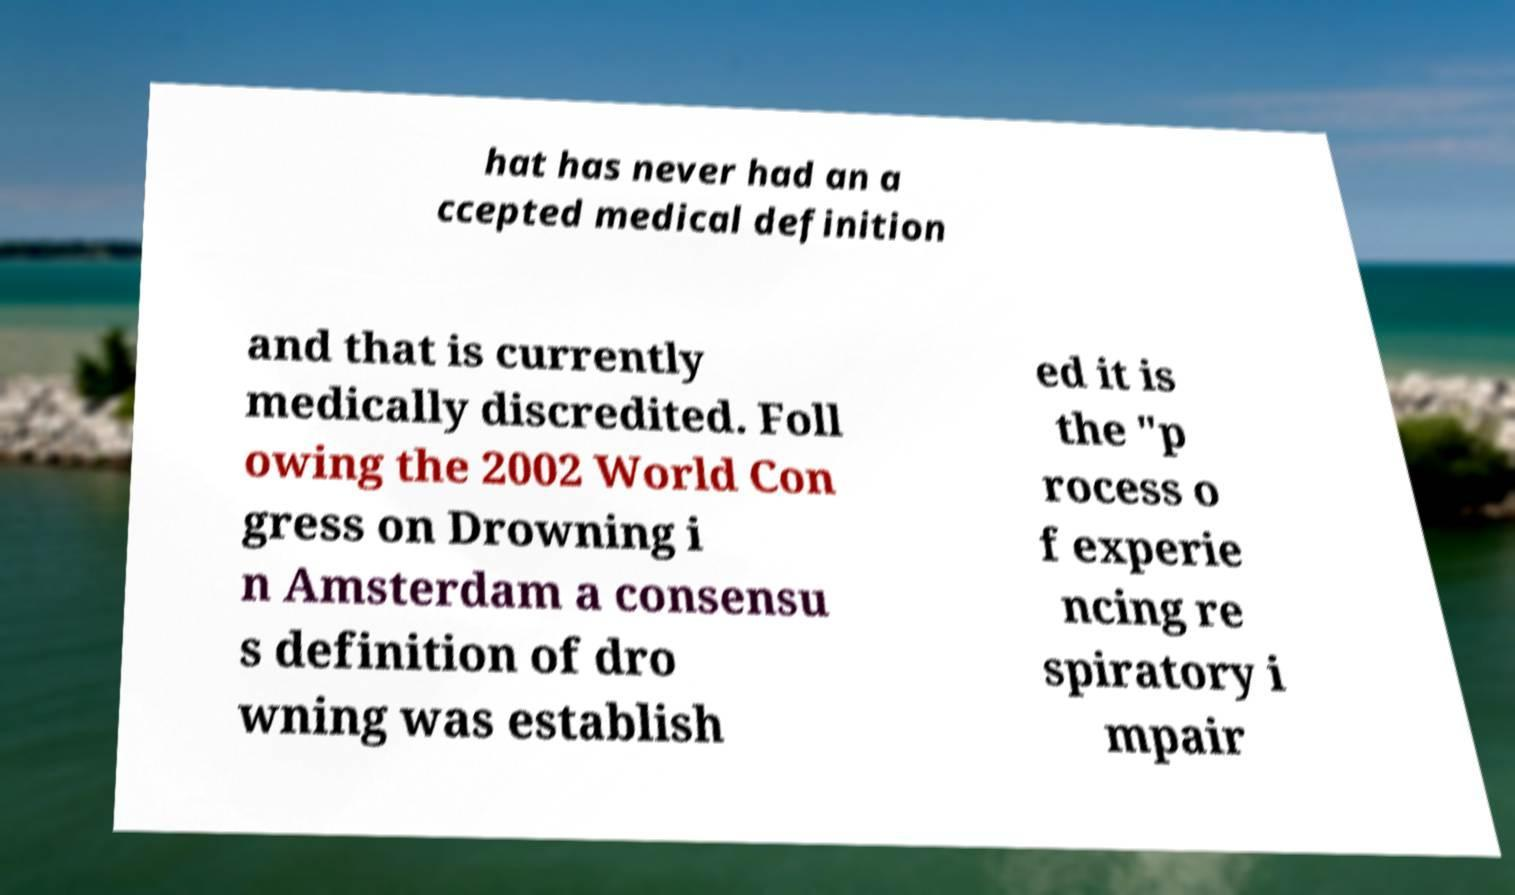I need the written content from this picture converted into text. Can you do that? hat has never had an a ccepted medical definition and that is currently medically discredited. Foll owing the 2002 World Con gress on Drowning i n Amsterdam a consensu s definition of dro wning was establish ed it is the "p rocess o f experie ncing re spiratory i mpair 